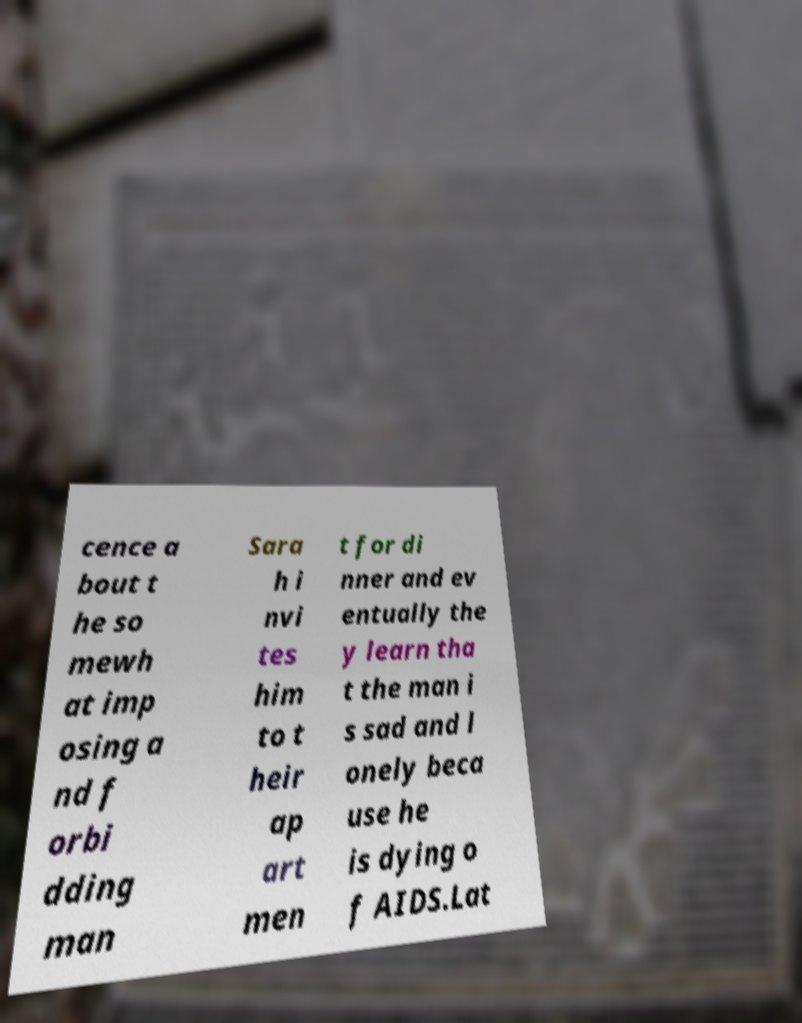What messages or text are displayed in this image? I need them in a readable, typed format. cence a bout t he so mewh at imp osing a nd f orbi dding man Sara h i nvi tes him to t heir ap art men t for di nner and ev entually the y learn tha t the man i s sad and l onely beca use he is dying o f AIDS.Lat 